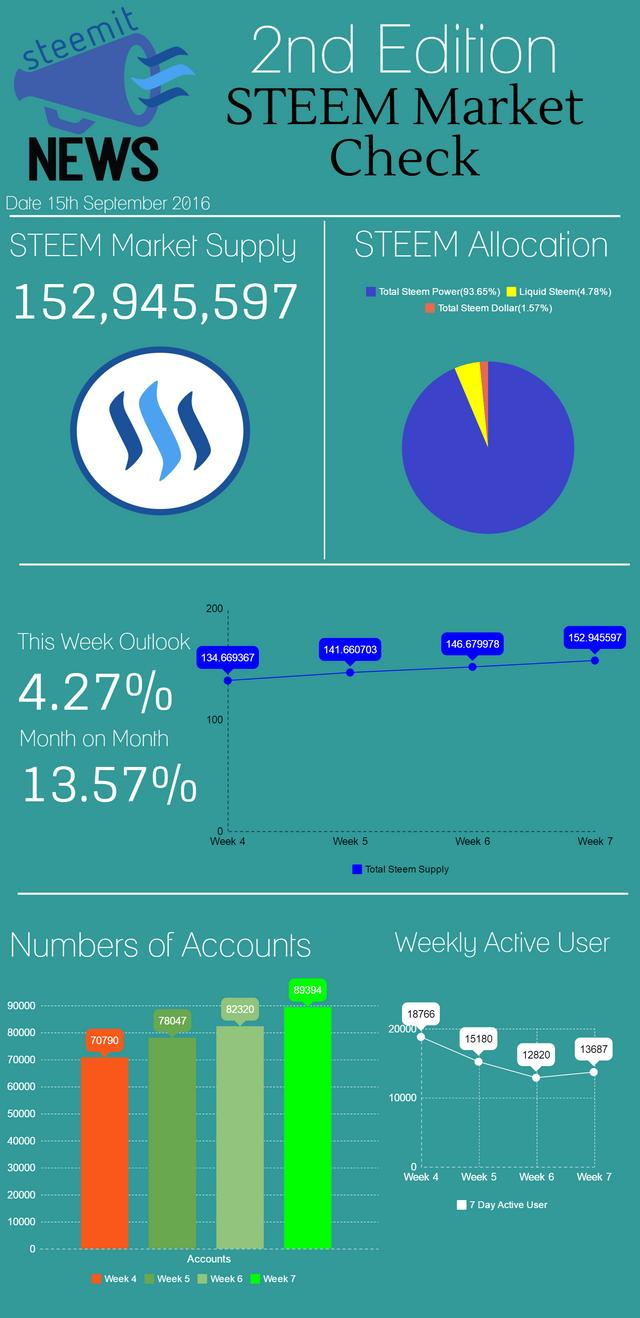Specify some key components in this picture. Which has the highest share of total STEEM dollar, total STEEM power, and total STEEM power... In week 4, the total number of accounts was 148,837, and in week 5, the total number of accounts was 148,837. 